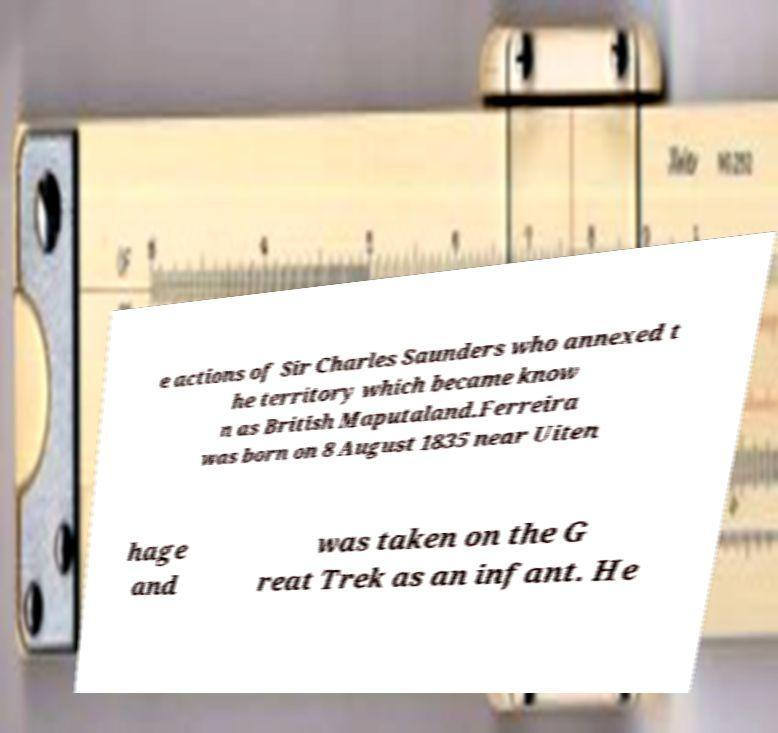There's text embedded in this image that I need extracted. Can you transcribe it verbatim? e actions of Sir Charles Saunders who annexed t he territory which became know n as British Maputaland.Ferreira was born on 8 August 1835 near Uiten hage and was taken on the G reat Trek as an infant. He 